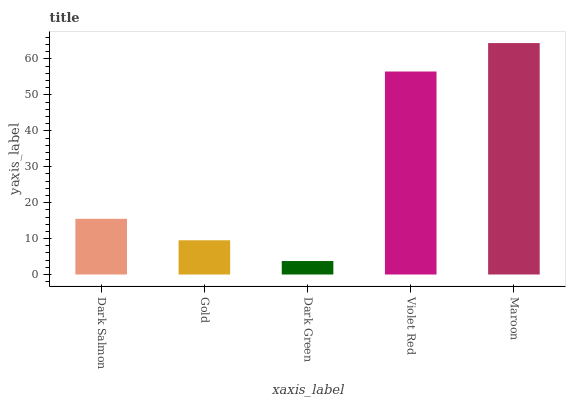Is Dark Green the minimum?
Answer yes or no. Yes. Is Maroon the maximum?
Answer yes or no. Yes. Is Gold the minimum?
Answer yes or no. No. Is Gold the maximum?
Answer yes or no. No. Is Dark Salmon greater than Gold?
Answer yes or no. Yes. Is Gold less than Dark Salmon?
Answer yes or no. Yes. Is Gold greater than Dark Salmon?
Answer yes or no. No. Is Dark Salmon less than Gold?
Answer yes or no. No. Is Dark Salmon the high median?
Answer yes or no. Yes. Is Dark Salmon the low median?
Answer yes or no. Yes. Is Violet Red the high median?
Answer yes or no. No. Is Dark Green the low median?
Answer yes or no. No. 